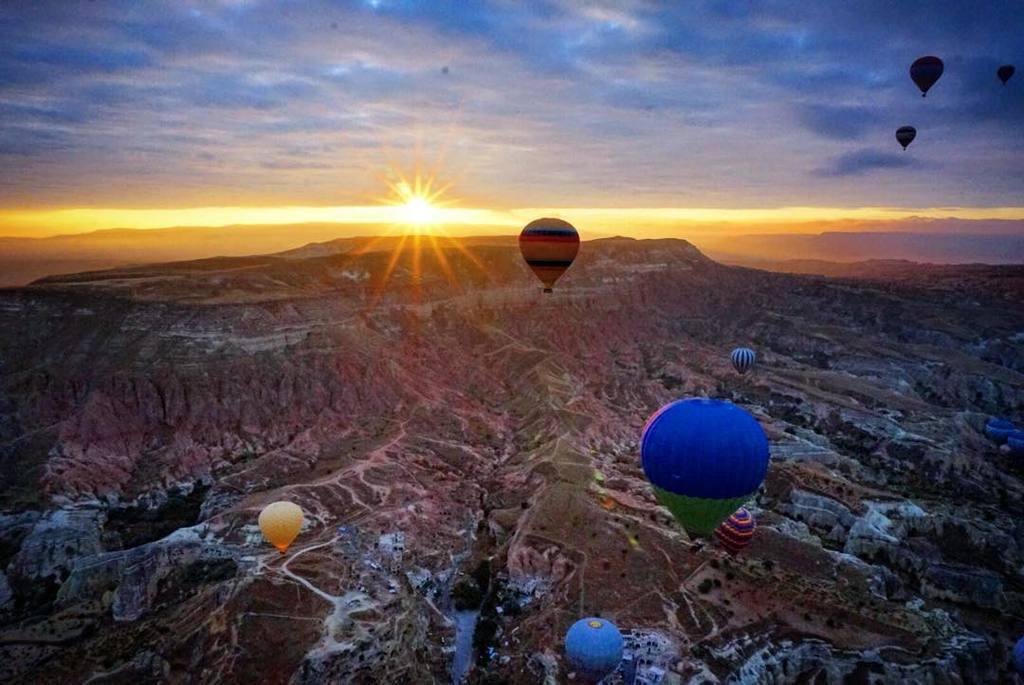What objects are present in the image related to aerial activities? There are parachutes in the image. What type of natural landscape can be seen in the background of the image? Hills are visible in the background of the image. What is the weather like in the image? The sky is visible, and there are clouds and the sun observable in the sky. How many snakes are crawling on the parachutes in the image? There are no snakes present in the image; it features parachutes and a natural landscape. What color is the mom's hair in the image? There is no mom or any person present in the image; it only shows parachutes, hills, and the sky. 